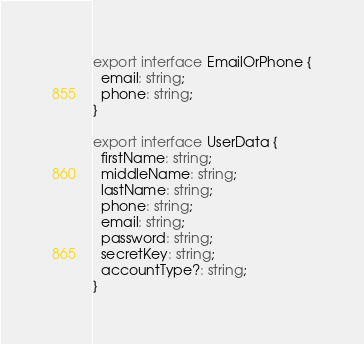Convert code to text. <code><loc_0><loc_0><loc_500><loc_500><_TypeScript_>export interface EmailOrPhone {
  email: string;
  phone: string;
}

export interface UserData {
  firstName: string;
  middleName: string;
  lastName: string;
  phone: string;
  email: string;
  password: string;
  secretKey: string;
  accountType?: string;
}
</code> 